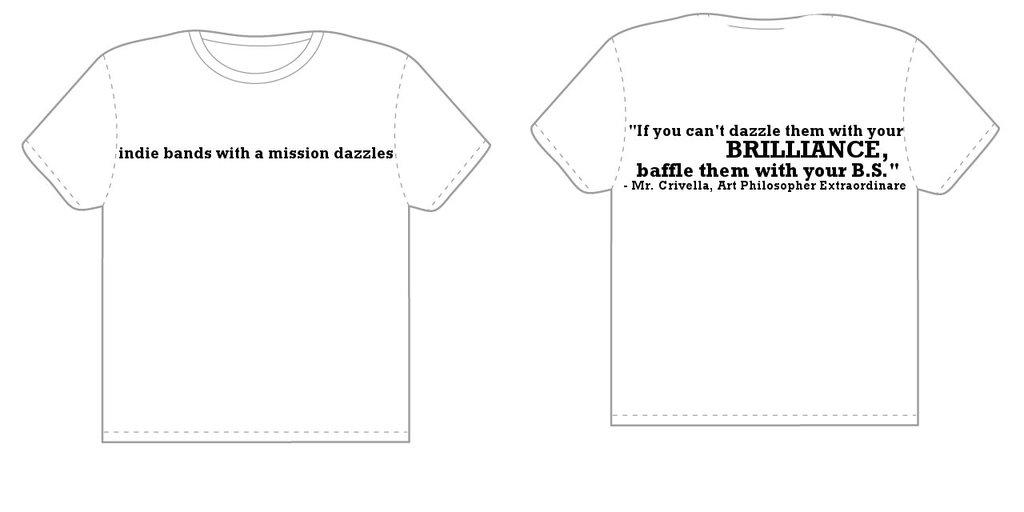<image>
Write a terse but informative summary of the picture. A shirt pattern has the word brilliance on it in larger font than the rest. 